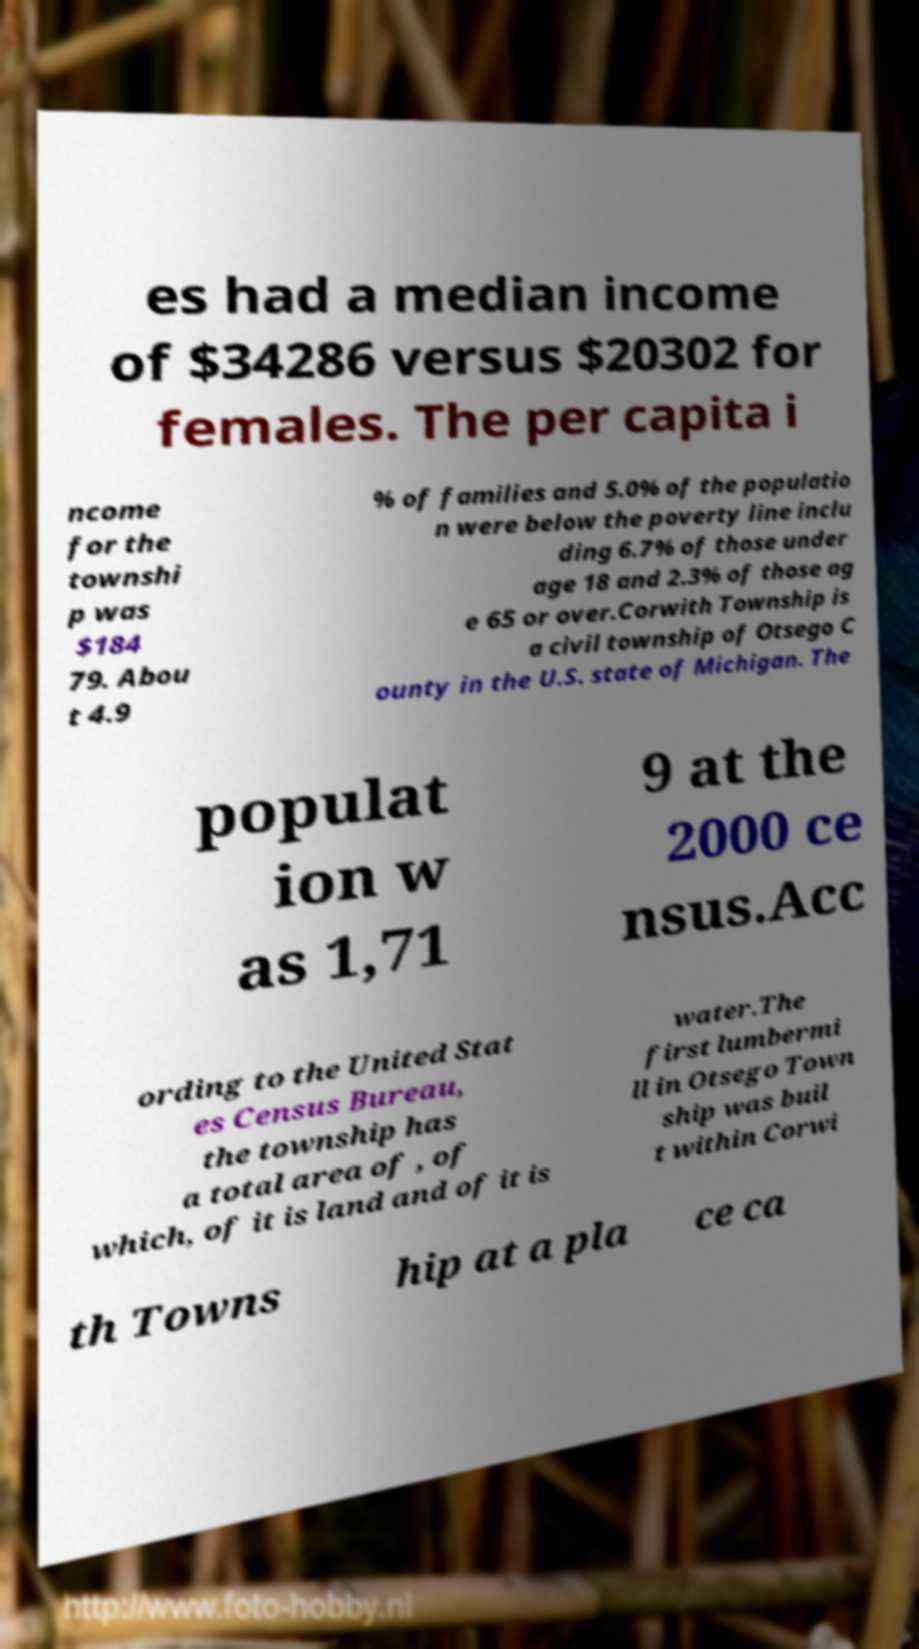Can you accurately transcribe the text from the provided image for me? es had a median income of $34286 versus $20302 for females. The per capita i ncome for the townshi p was $184 79. Abou t 4.9 % of families and 5.0% of the populatio n were below the poverty line inclu ding 6.7% of those under age 18 and 2.3% of those ag e 65 or over.Corwith Township is a civil township of Otsego C ounty in the U.S. state of Michigan. The populat ion w as 1,71 9 at the 2000 ce nsus.Acc ording to the United Stat es Census Bureau, the township has a total area of , of which, of it is land and of it is water.The first lumbermi ll in Otsego Town ship was buil t within Corwi th Towns hip at a pla ce ca 